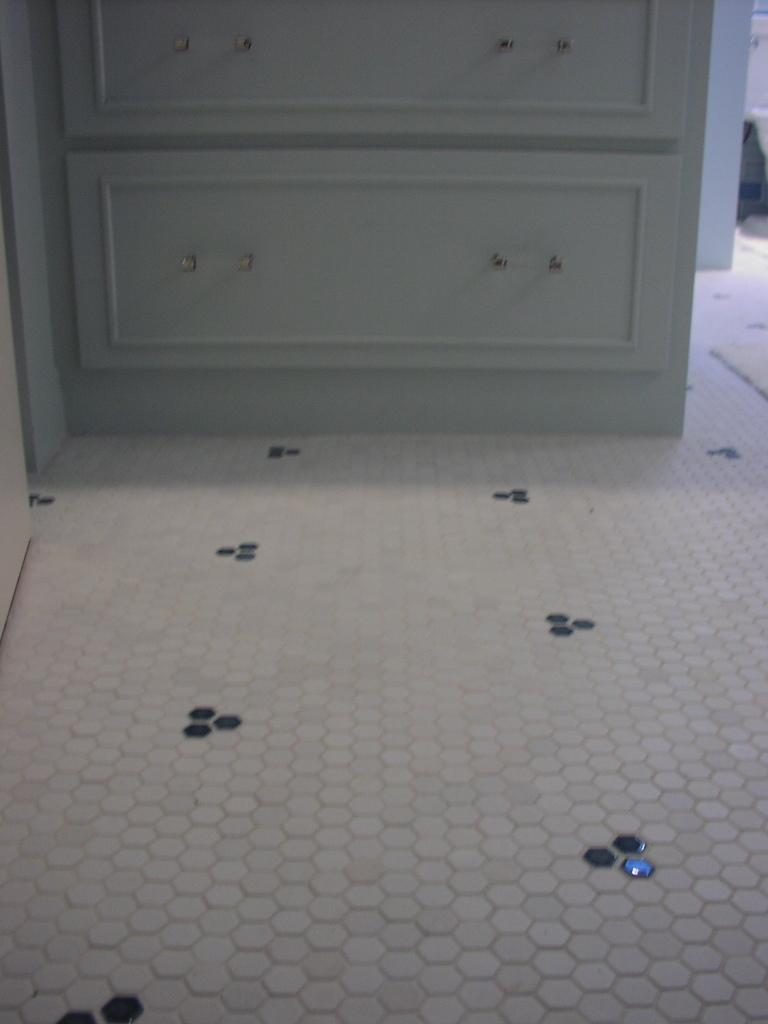What is the primary surface visible in the image? There is a floor in the image. Can you describe the appearance of the floor? The floor has designs on it. What type of furniture can be seen in the background of the image? There is a cupboard in the background of the image. What type of meat is being prepared on the floor in the image? There is no meat or any indication of food preparation in the image; it primarily features a floor with designs. 